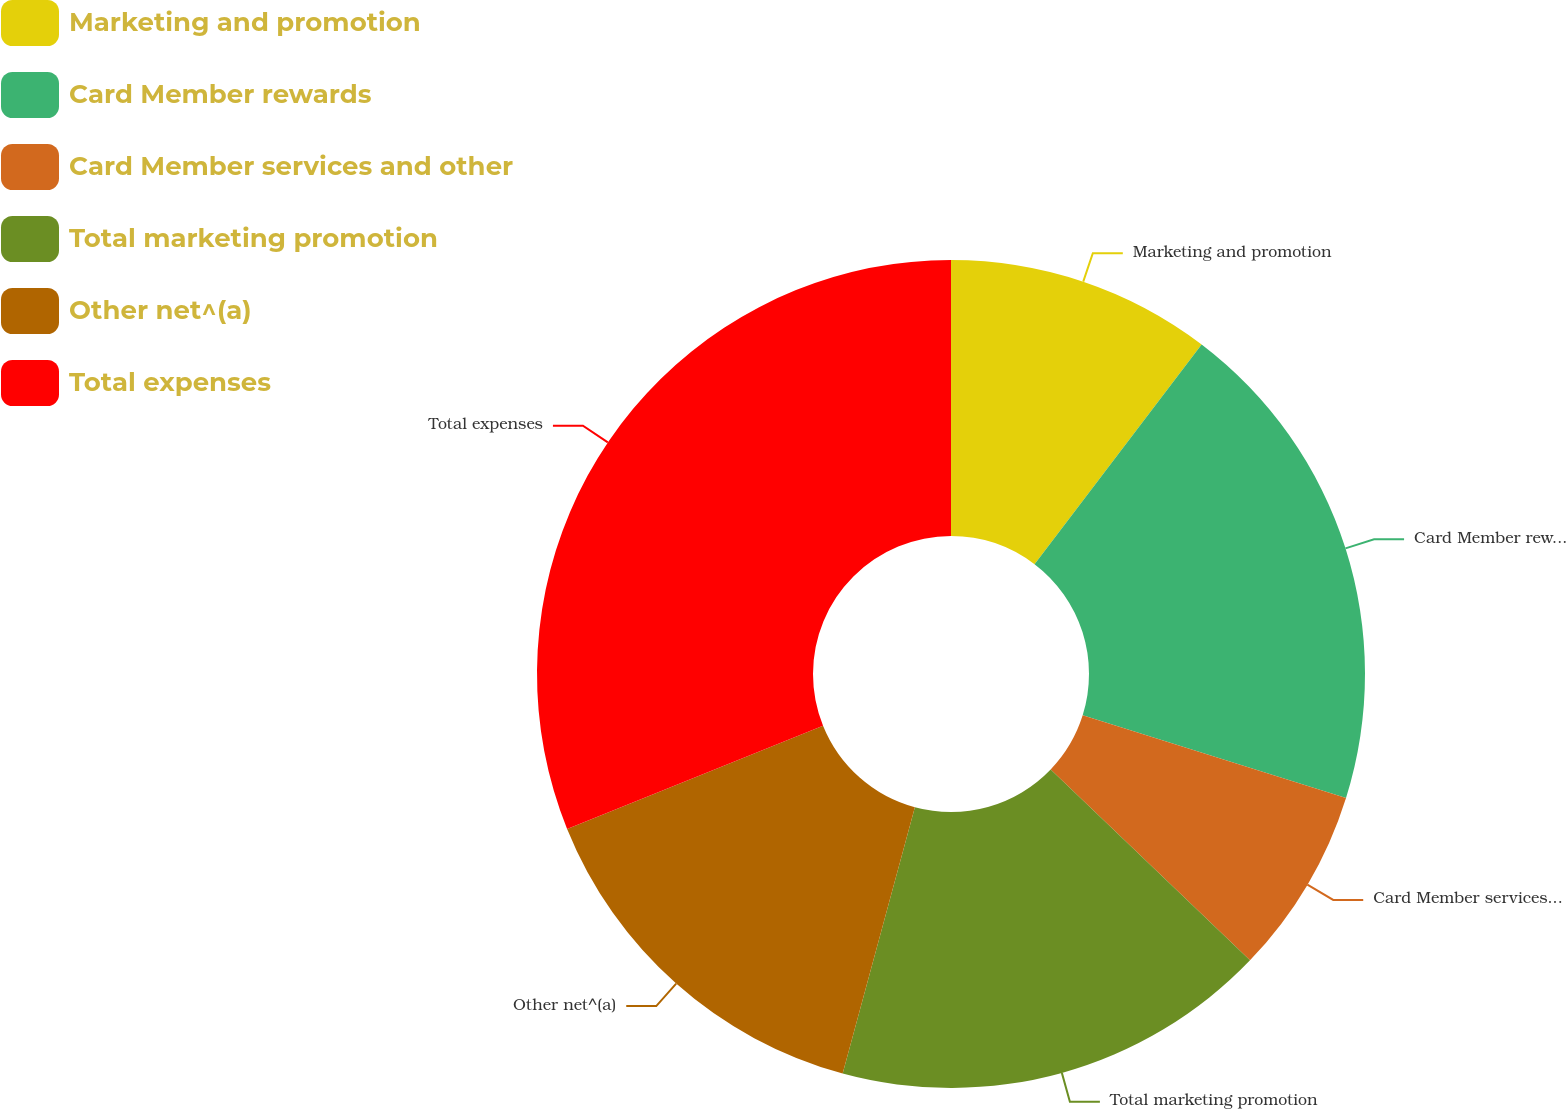Convert chart to OTSL. <chart><loc_0><loc_0><loc_500><loc_500><pie_chart><fcel>Marketing and promotion<fcel>Card Member rewards<fcel>Card Member services and other<fcel>Total marketing promotion<fcel>Other net^(a)<fcel>Total expenses<nl><fcel>10.35%<fcel>19.49%<fcel>7.32%<fcel>17.06%<fcel>14.68%<fcel>31.11%<nl></chart> 